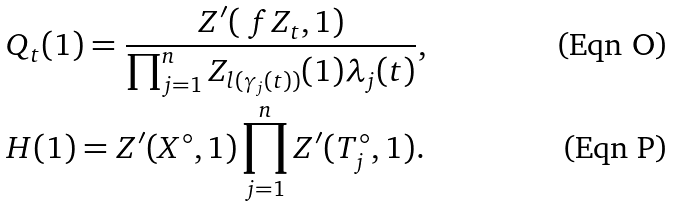<formula> <loc_0><loc_0><loc_500><loc_500>& Q _ { t } ( 1 ) = \frac { Z ^ { \prime } ( \ f Z _ { t } , 1 ) } { \prod _ { j = 1 } ^ { n } Z _ { l ( \gamma _ { j } ( t ) ) } ( 1 ) \lambda _ { j } ( t ) } , \\ & H ( 1 ) = Z ^ { \prime } ( X ^ { \circ } , 1 ) \prod _ { j = 1 } ^ { n } Z ^ { \prime } ( T _ { j } ^ { \circ } , 1 ) .</formula> 